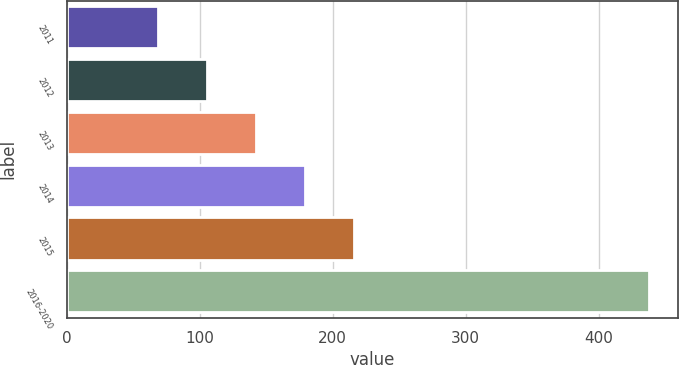Convert chart to OTSL. <chart><loc_0><loc_0><loc_500><loc_500><bar_chart><fcel>2011<fcel>2012<fcel>2013<fcel>2014<fcel>2015<fcel>2016-2020<nl><fcel>68.5<fcel>105.45<fcel>142.4<fcel>179.35<fcel>216.3<fcel>438<nl></chart> 